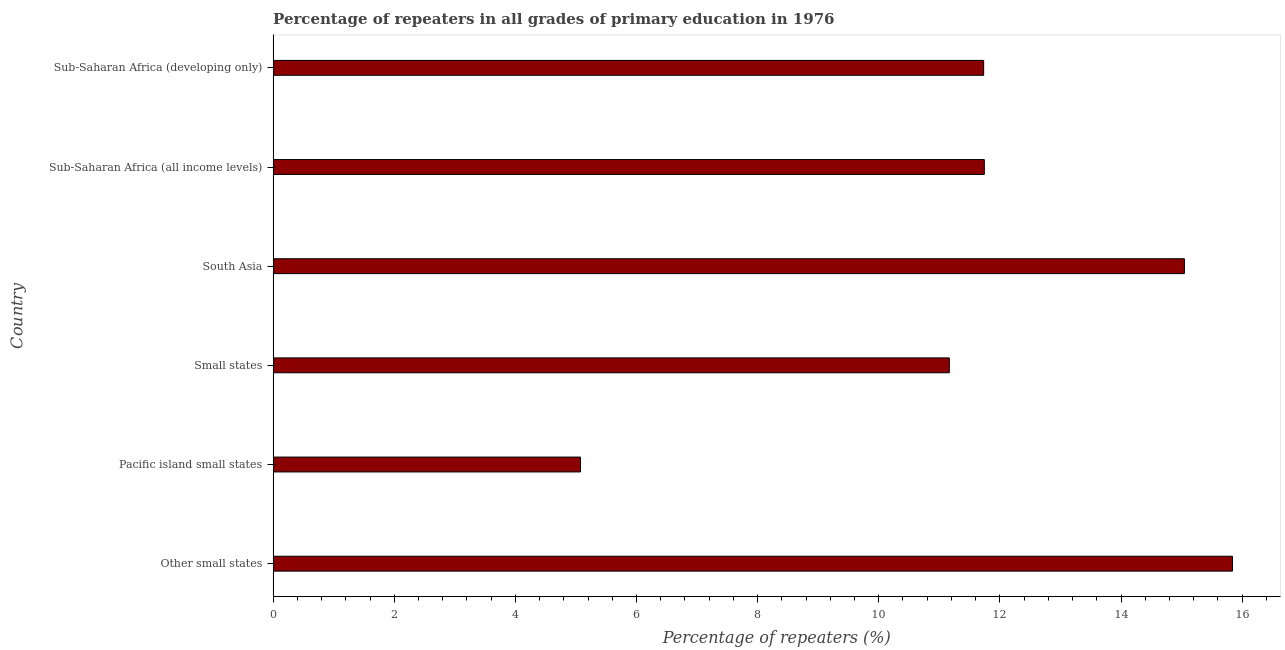Does the graph contain any zero values?
Your answer should be compact. No. Does the graph contain grids?
Ensure brevity in your answer.  No. What is the title of the graph?
Keep it short and to the point. Percentage of repeaters in all grades of primary education in 1976. What is the label or title of the X-axis?
Keep it short and to the point. Percentage of repeaters (%). What is the label or title of the Y-axis?
Give a very brief answer. Country. What is the percentage of repeaters in primary education in Pacific island small states?
Ensure brevity in your answer.  5.08. Across all countries, what is the maximum percentage of repeaters in primary education?
Offer a very short reply. 15.84. Across all countries, what is the minimum percentage of repeaters in primary education?
Your answer should be compact. 5.08. In which country was the percentage of repeaters in primary education maximum?
Your answer should be compact. Other small states. In which country was the percentage of repeaters in primary education minimum?
Keep it short and to the point. Pacific island small states. What is the sum of the percentage of repeaters in primary education?
Your answer should be compact. 70.6. What is the difference between the percentage of repeaters in primary education in Other small states and Sub-Saharan Africa (all income levels)?
Make the answer very short. 4.1. What is the average percentage of repeaters in primary education per country?
Ensure brevity in your answer.  11.77. What is the median percentage of repeaters in primary education?
Give a very brief answer. 11.74. In how many countries, is the percentage of repeaters in primary education greater than 5.2 %?
Provide a short and direct response. 5. What is the ratio of the percentage of repeaters in primary education in Small states to that in South Asia?
Your answer should be compact. 0.74. What is the difference between the highest and the second highest percentage of repeaters in primary education?
Your response must be concise. 0.79. What is the difference between the highest and the lowest percentage of repeaters in primary education?
Offer a very short reply. 10.77. In how many countries, is the percentage of repeaters in primary education greater than the average percentage of repeaters in primary education taken over all countries?
Offer a very short reply. 2. How many bars are there?
Your answer should be very brief. 6. How many countries are there in the graph?
Give a very brief answer. 6. What is the difference between two consecutive major ticks on the X-axis?
Provide a short and direct response. 2. Are the values on the major ticks of X-axis written in scientific E-notation?
Your response must be concise. No. What is the Percentage of repeaters (%) of Other small states?
Keep it short and to the point. 15.84. What is the Percentage of repeaters (%) in Pacific island small states?
Ensure brevity in your answer.  5.08. What is the Percentage of repeaters (%) of Small states?
Ensure brevity in your answer.  11.17. What is the Percentage of repeaters (%) in South Asia?
Provide a succinct answer. 15.05. What is the Percentage of repeaters (%) in Sub-Saharan Africa (all income levels)?
Keep it short and to the point. 11.74. What is the Percentage of repeaters (%) in Sub-Saharan Africa (developing only)?
Provide a short and direct response. 11.73. What is the difference between the Percentage of repeaters (%) in Other small states and Pacific island small states?
Offer a very short reply. 10.77. What is the difference between the Percentage of repeaters (%) in Other small states and Small states?
Your response must be concise. 4.68. What is the difference between the Percentage of repeaters (%) in Other small states and South Asia?
Provide a short and direct response. 0.79. What is the difference between the Percentage of repeaters (%) in Other small states and Sub-Saharan Africa (all income levels)?
Ensure brevity in your answer.  4.1. What is the difference between the Percentage of repeaters (%) in Other small states and Sub-Saharan Africa (developing only)?
Ensure brevity in your answer.  4.11. What is the difference between the Percentage of repeaters (%) in Pacific island small states and Small states?
Ensure brevity in your answer.  -6.09. What is the difference between the Percentage of repeaters (%) in Pacific island small states and South Asia?
Provide a succinct answer. -9.97. What is the difference between the Percentage of repeaters (%) in Pacific island small states and Sub-Saharan Africa (all income levels)?
Your answer should be compact. -6.67. What is the difference between the Percentage of repeaters (%) in Pacific island small states and Sub-Saharan Africa (developing only)?
Your answer should be very brief. -6.66. What is the difference between the Percentage of repeaters (%) in Small states and South Asia?
Your answer should be very brief. -3.88. What is the difference between the Percentage of repeaters (%) in Small states and Sub-Saharan Africa (all income levels)?
Offer a terse response. -0.58. What is the difference between the Percentage of repeaters (%) in Small states and Sub-Saharan Africa (developing only)?
Offer a very short reply. -0.57. What is the difference between the Percentage of repeaters (%) in South Asia and Sub-Saharan Africa (all income levels)?
Your answer should be very brief. 3.3. What is the difference between the Percentage of repeaters (%) in South Asia and Sub-Saharan Africa (developing only)?
Your answer should be very brief. 3.31. What is the difference between the Percentage of repeaters (%) in Sub-Saharan Africa (all income levels) and Sub-Saharan Africa (developing only)?
Your answer should be compact. 0.01. What is the ratio of the Percentage of repeaters (%) in Other small states to that in Pacific island small states?
Offer a very short reply. 3.12. What is the ratio of the Percentage of repeaters (%) in Other small states to that in Small states?
Keep it short and to the point. 1.42. What is the ratio of the Percentage of repeaters (%) in Other small states to that in South Asia?
Offer a very short reply. 1.05. What is the ratio of the Percentage of repeaters (%) in Other small states to that in Sub-Saharan Africa (all income levels)?
Your response must be concise. 1.35. What is the ratio of the Percentage of repeaters (%) in Other small states to that in Sub-Saharan Africa (developing only)?
Offer a terse response. 1.35. What is the ratio of the Percentage of repeaters (%) in Pacific island small states to that in Small states?
Provide a short and direct response. 0.46. What is the ratio of the Percentage of repeaters (%) in Pacific island small states to that in South Asia?
Provide a short and direct response. 0.34. What is the ratio of the Percentage of repeaters (%) in Pacific island small states to that in Sub-Saharan Africa (all income levels)?
Your response must be concise. 0.43. What is the ratio of the Percentage of repeaters (%) in Pacific island small states to that in Sub-Saharan Africa (developing only)?
Provide a short and direct response. 0.43. What is the ratio of the Percentage of repeaters (%) in Small states to that in South Asia?
Make the answer very short. 0.74. What is the ratio of the Percentage of repeaters (%) in Small states to that in Sub-Saharan Africa (all income levels)?
Ensure brevity in your answer.  0.95. What is the ratio of the Percentage of repeaters (%) in Small states to that in Sub-Saharan Africa (developing only)?
Keep it short and to the point. 0.95. What is the ratio of the Percentage of repeaters (%) in South Asia to that in Sub-Saharan Africa (all income levels)?
Keep it short and to the point. 1.28. What is the ratio of the Percentage of repeaters (%) in South Asia to that in Sub-Saharan Africa (developing only)?
Offer a terse response. 1.28. 